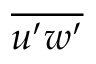<formula> <loc_0><loc_0><loc_500><loc_500>\overline { { u ^ { \prime } w ^ { \prime } } }</formula> 